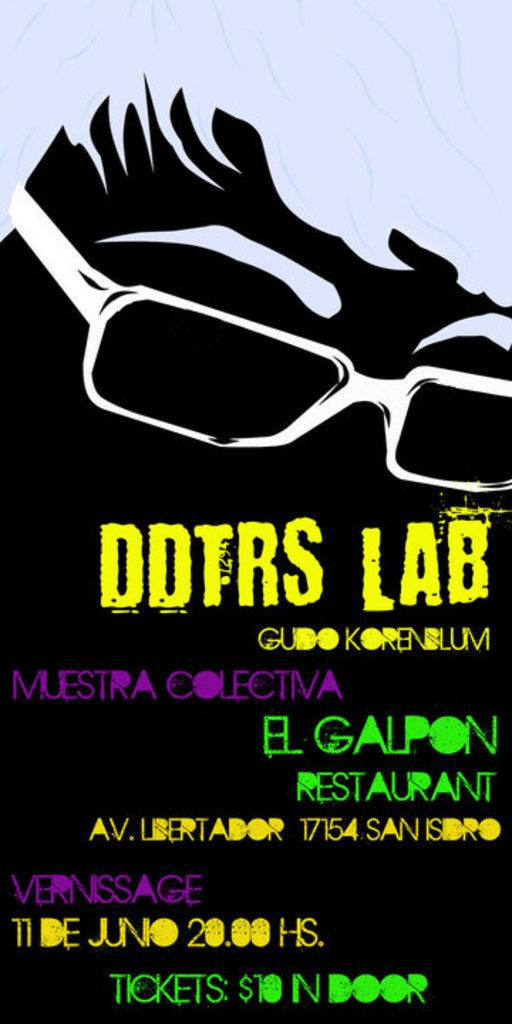What is the main subject in the center of the image? There is a poster in the center of the image. What can be read on the poster? The poster has the text "DDTRS LABS" written on it. How many tents are set up near the poster in the image? There are no tents present in the image; it only features a poster with the text "DDTRS LABS." 